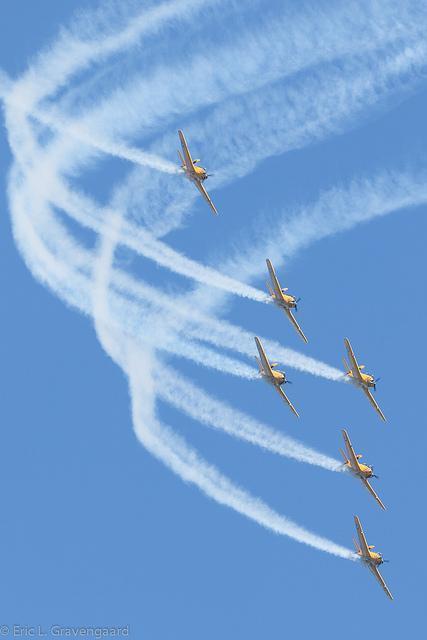How many planes are there?
Give a very brief answer. 6. 